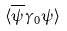Convert formula to latex. <formula><loc_0><loc_0><loc_500><loc_500>\langle \overline { \psi } \gamma _ { 0 } \psi \rangle</formula> 